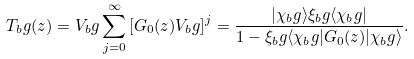<formula> <loc_0><loc_0><loc_500><loc_500>T _ { b } g ( z ) = V _ { b } g \sum _ { j = 0 } ^ { \infty } \left [ G _ { 0 } ( z ) V _ { b } g \right ] ^ { j } = \frac { | \chi _ { b } g \rangle \xi _ { b } g \langle \chi _ { b } g | } { 1 - \xi _ { b } g \langle \chi _ { b } g | G _ { 0 } ( z ) | \chi _ { b } g \rangle } .</formula> 